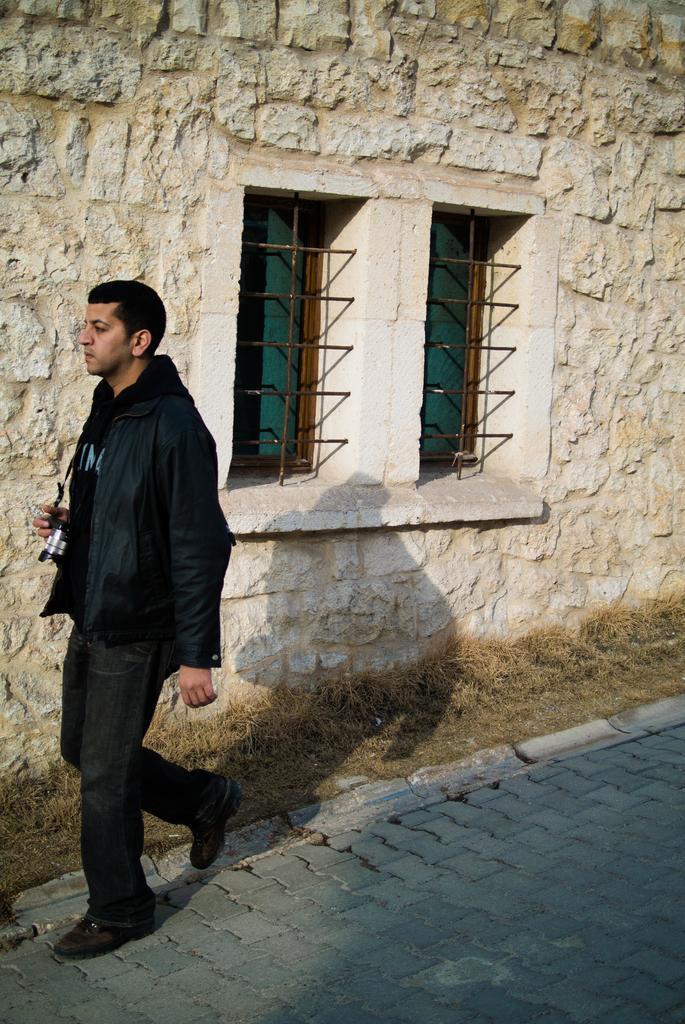In one or two sentences, can you explain what this image depicts? In this image I can see on the left side a man is walking, he wears a black color coat, trouser, shoes. In the middle there are windows on the stone wall. 